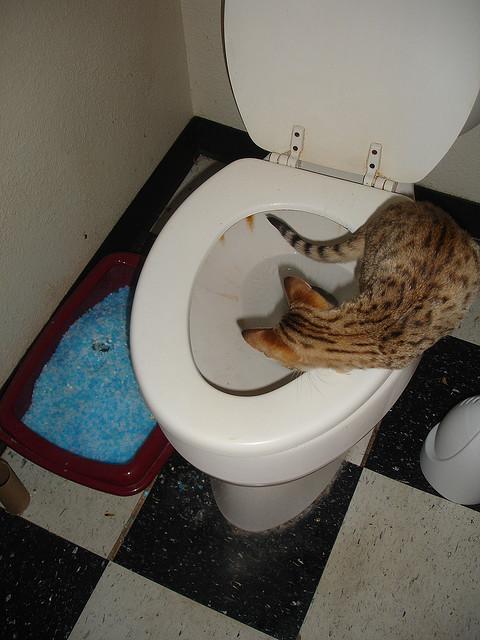What color is the cat?
Write a very short answer. Brown. Is the bathroom currently vacant?
Answer briefly. No. Is the cat multicolored?
Quick response, please. Yes. Is the floor black and white?
Concise answer only. Yes. What is hanging out of the toilet?
Write a very short answer. Cat. What is growing out of the toilet?
Concise answer only. Cat. Is the cat going to fall in?
Concise answer only. No. What type of animal is in this photo?
Concise answer only. Cat. 